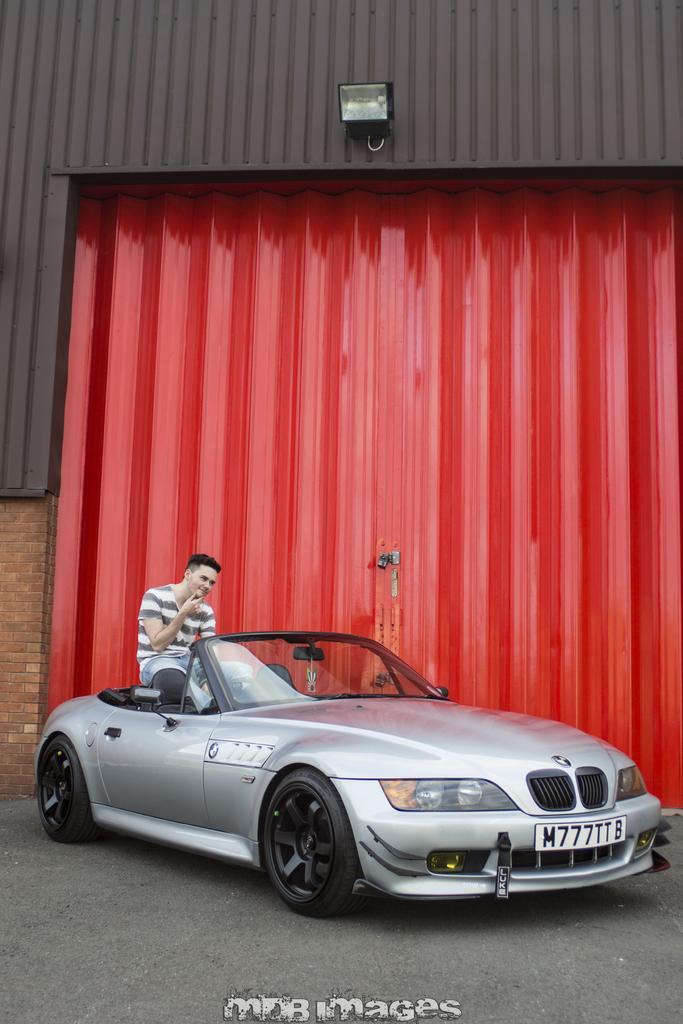Could you give a brief overview of what you see in this image? in the picture we can see a car along with the person sitting on it and back of the car there was shed in red color and top of the shed there was a light. 